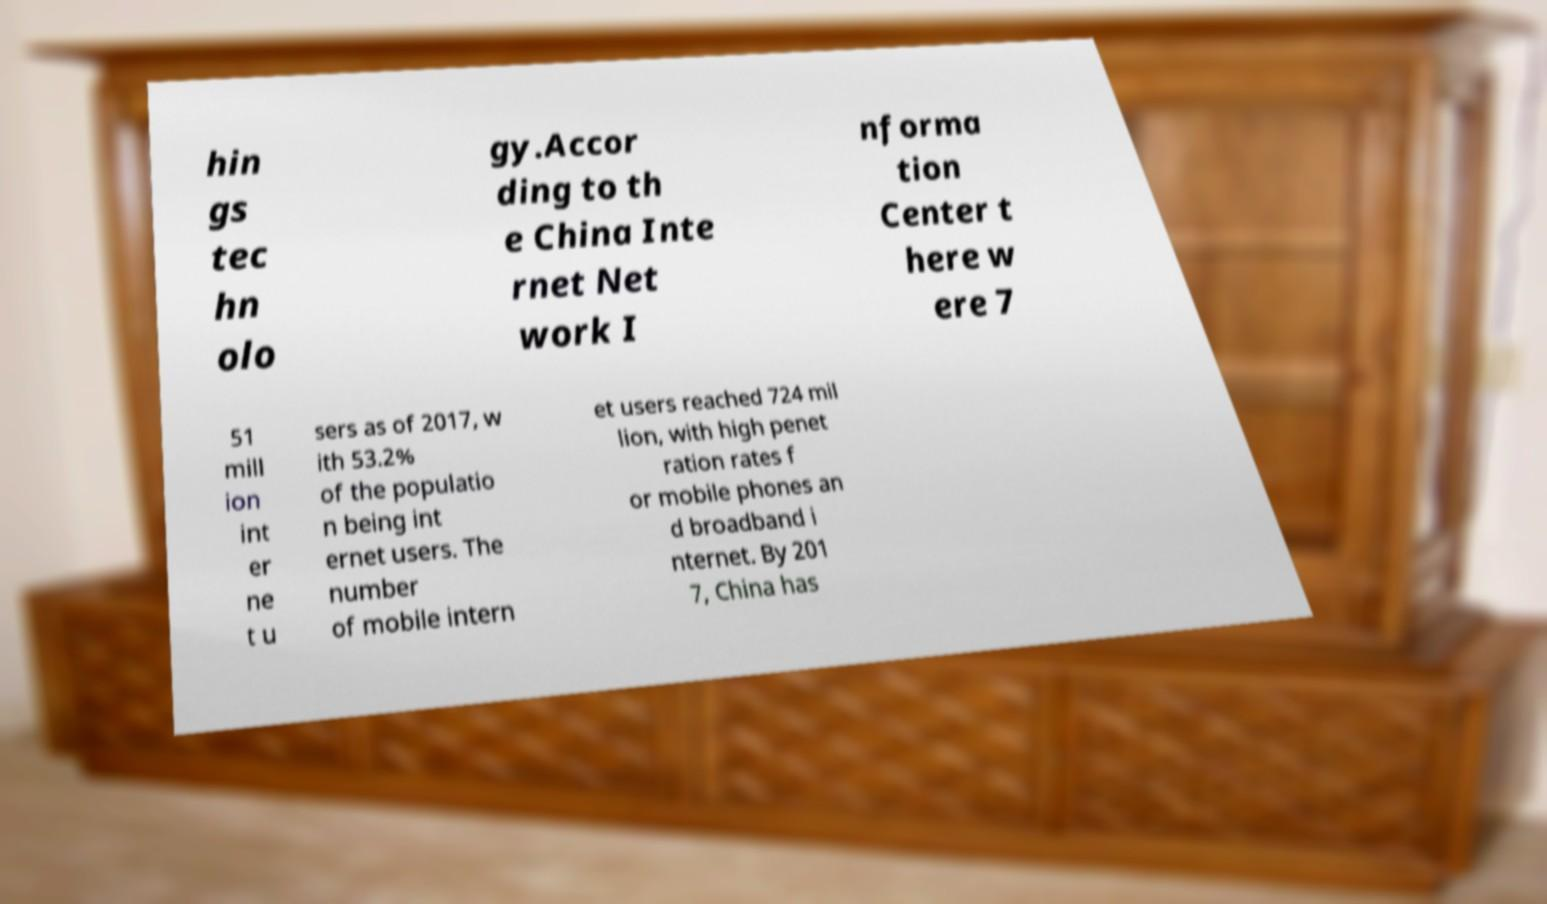Please read and relay the text visible in this image. What does it say? hin gs tec hn olo gy.Accor ding to th e China Inte rnet Net work I nforma tion Center t here w ere 7 51 mill ion int er ne t u sers as of 2017, w ith 53.2% of the populatio n being int ernet users. The number of mobile intern et users reached 724 mil lion, with high penet ration rates f or mobile phones an d broadband i nternet. By 201 7, China has 